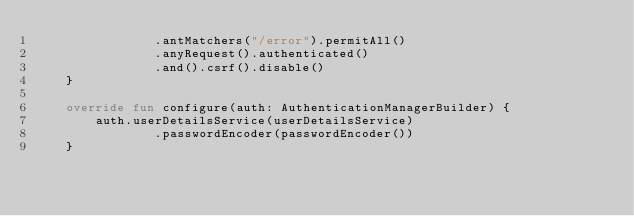<code> <loc_0><loc_0><loc_500><loc_500><_Kotlin_>                .antMatchers("/error").permitAll()
                .anyRequest().authenticated()
                .and().csrf().disable()
    }

    override fun configure(auth: AuthenticationManagerBuilder) {
        auth.userDetailsService(userDetailsService)
                .passwordEncoder(passwordEncoder())
    }
</code> 